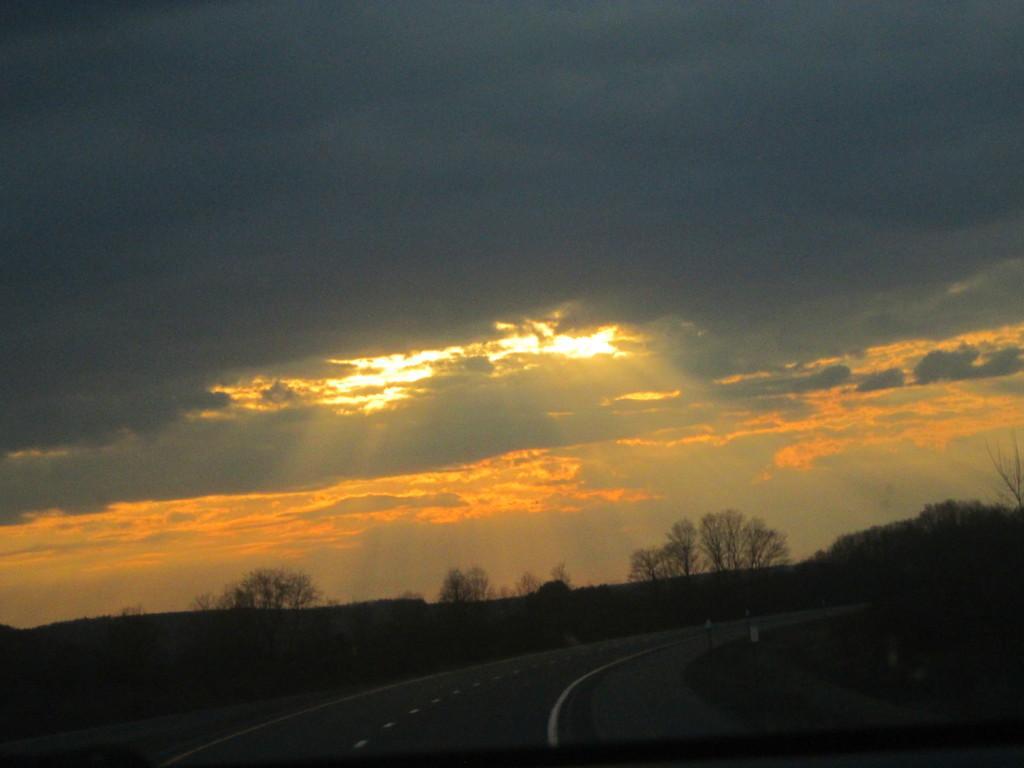Describe this image in one or two sentences. This is an outside view. At the bottom of the image I can see the road. On both sides of the road there are some trees. On the top of the image I can see the sky and clouds. 